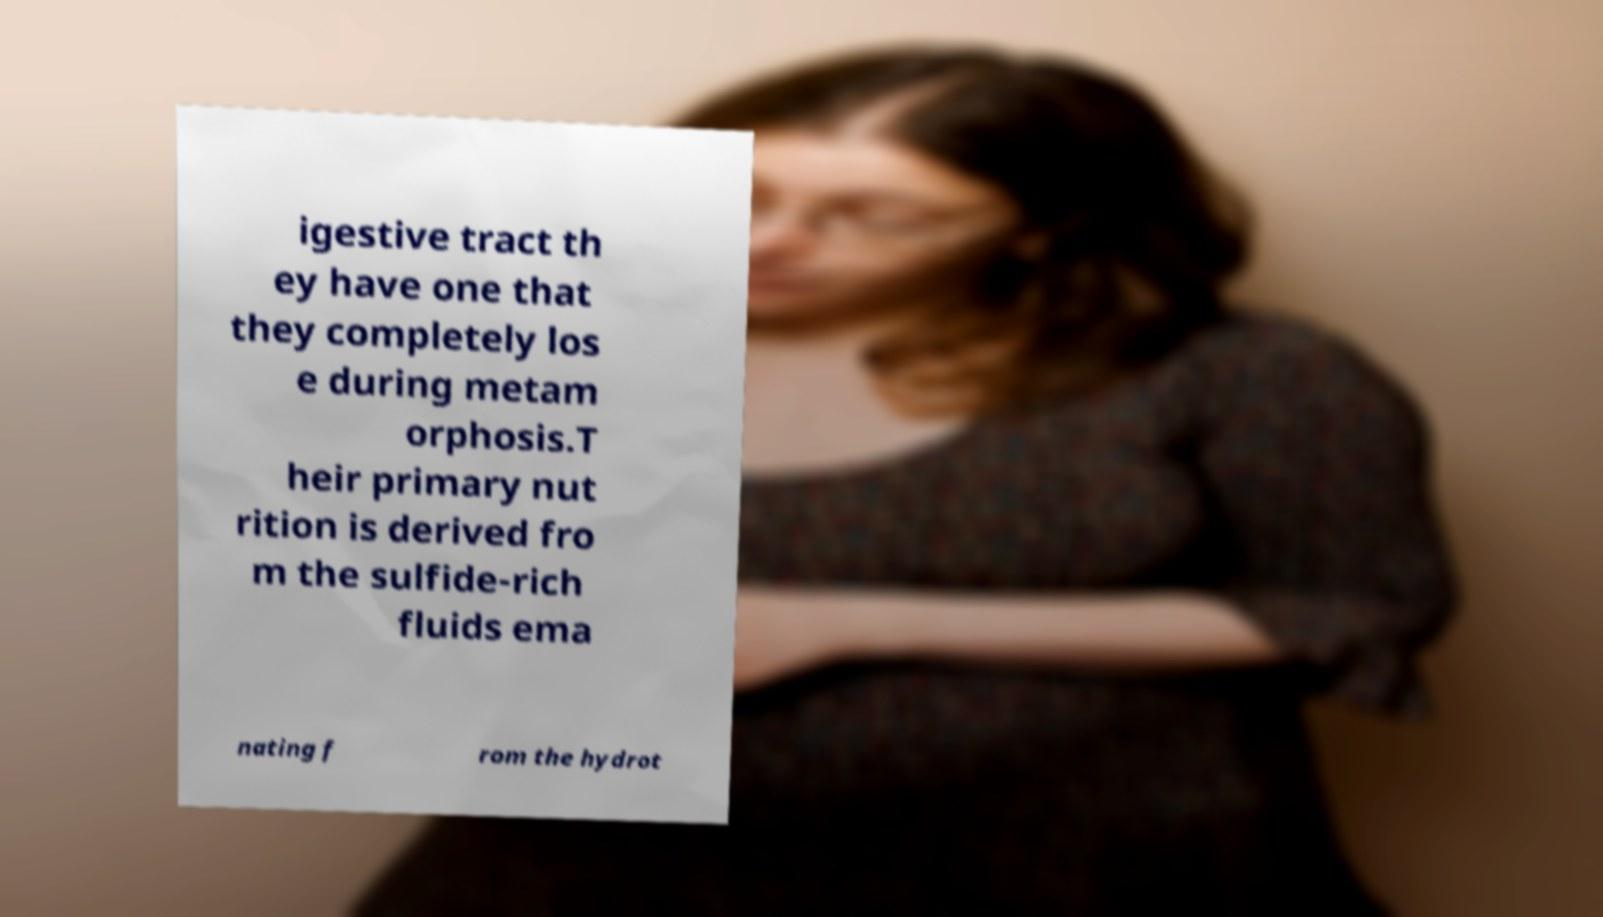I need the written content from this picture converted into text. Can you do that? igestive tract th ey have one that they completely los e during metam orphosis.T heir primary nut rition is derived fro m the sulfide-rich fluids ema nating f rom the hydrot 